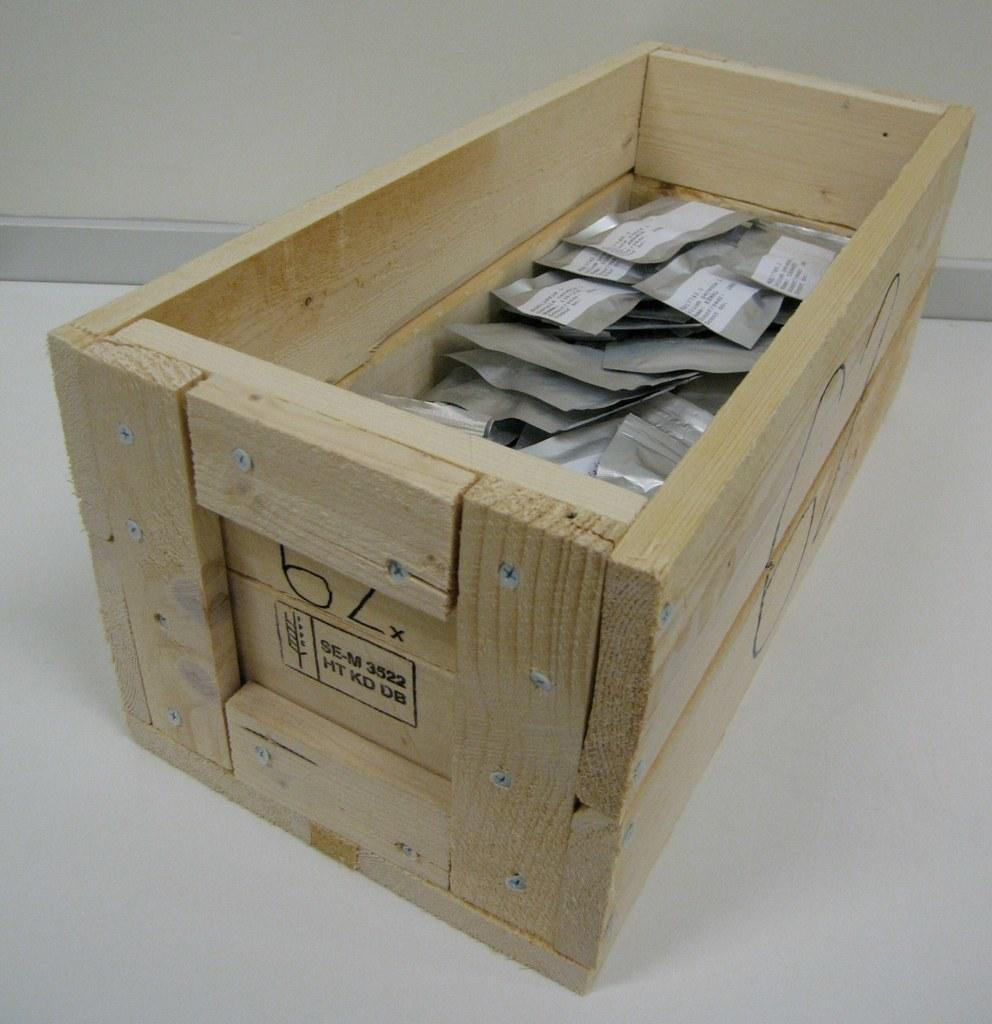<image>
Share a concise interpretation of the image provided. A wooden crate with the number 62 written on it. 